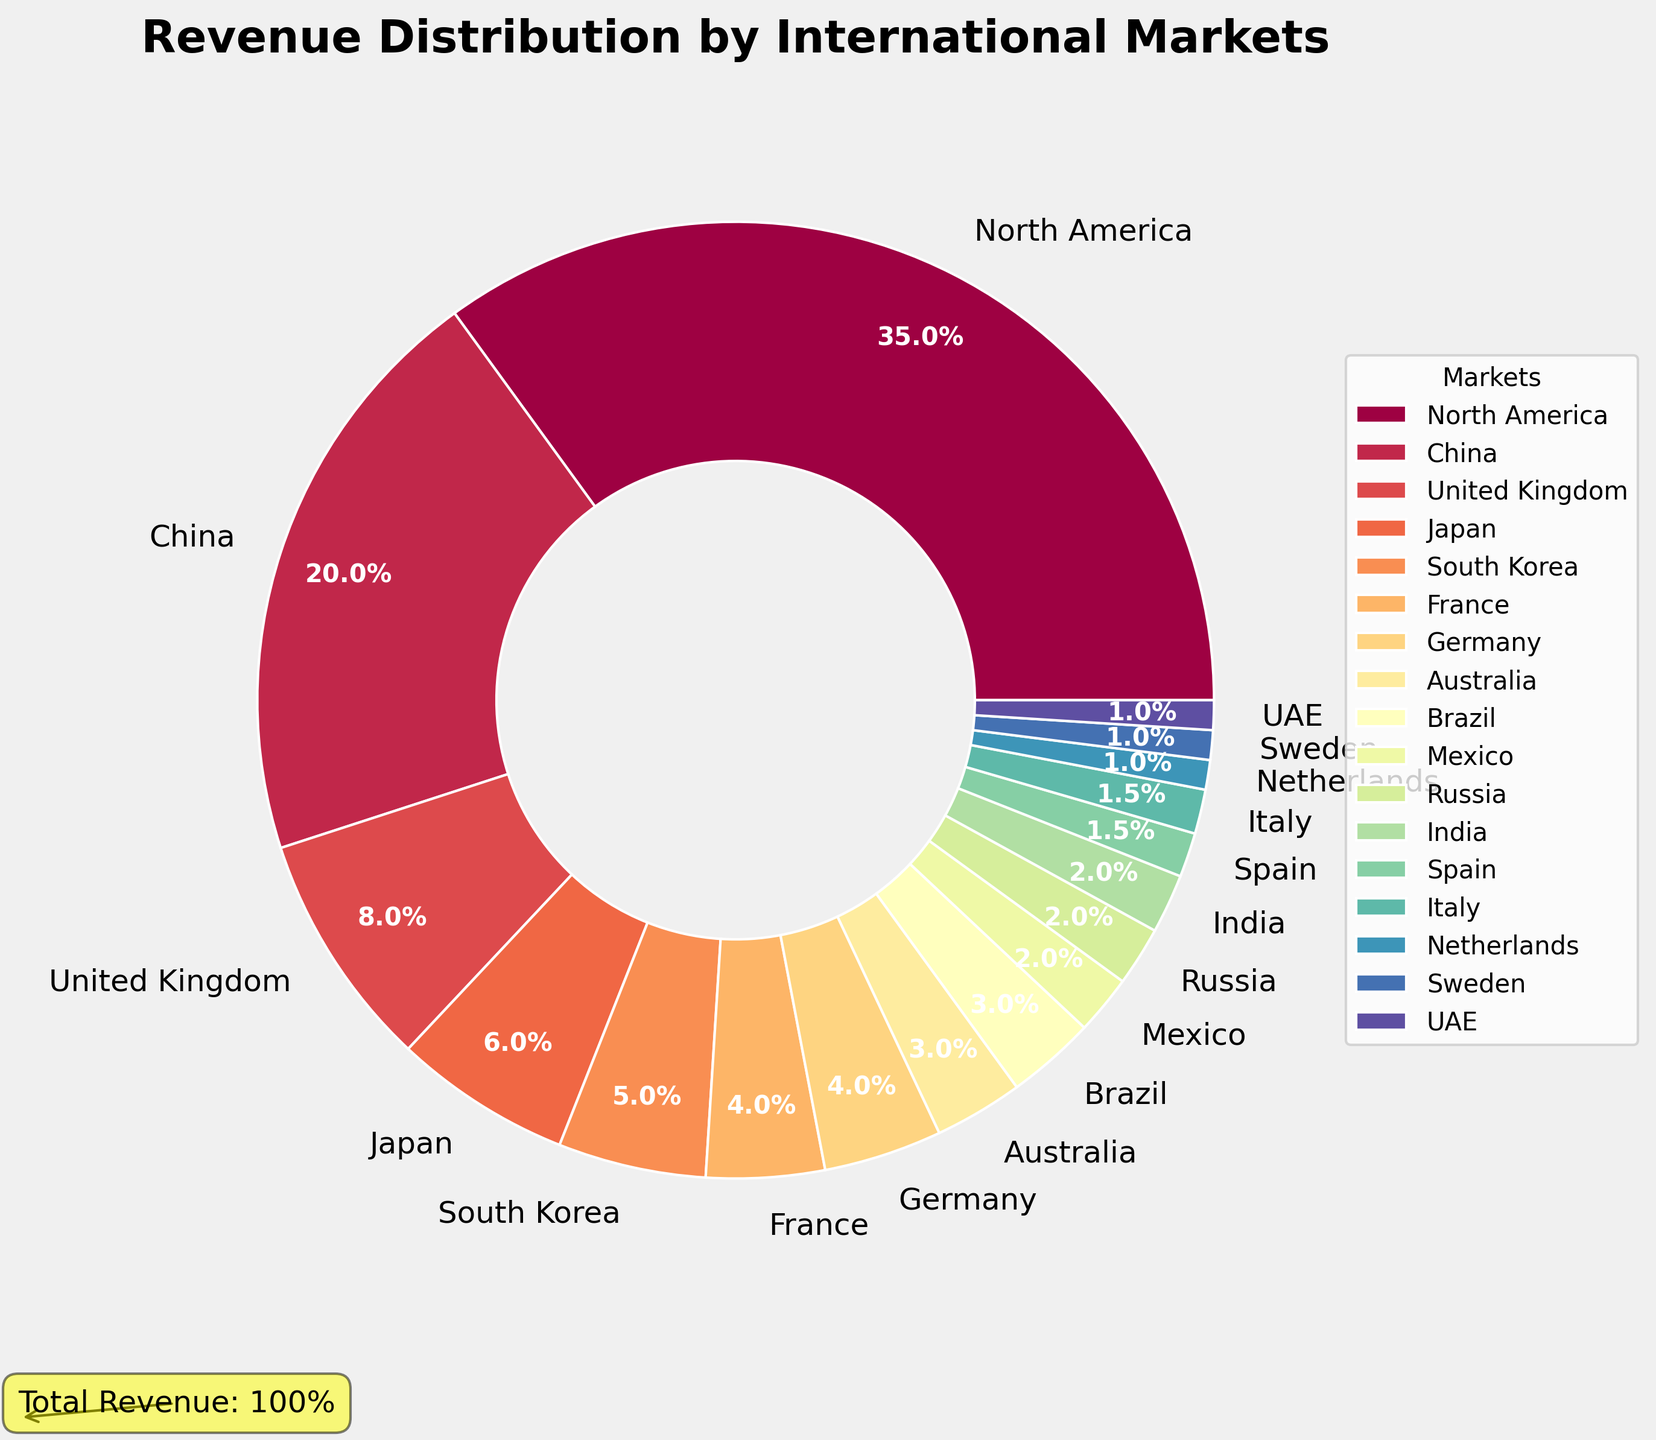What percentage of revenue does North America generate compared to China? North America generates 35% of the revenue, while China generates 20%. The comparison is 35% vs. 20%, indicating North America generates 15% more revenue than China.
Answer: 15% What's the combined revenue percentage generated by Japan, South Korea, and France? Add the percentages of Japan (6%), South Korea (5%), and France (4%). The combined revenue is 6% + 5% + 4% = 15%.
Answer: 15% Which market contributes less to the revenue: Mexico or Russia? Mexico contributes 2% and Russia also contributes 2%. They both contribute the same percentage.
Answer: They are equal What is the total percentage of revenue generated by markets contributing less than 5% each? Sum the percentages of markets contributing less than 5%: United Kingdom (8%), Japan (6%), South Korea (5%), France (4%), Germany (4%), Australia (3%), Brazil (3%), Mexico (2%), Russia (2%), India (2%), Spain (1.5%), Italy (1.5%), Netherlands (1%), Sweden (1%), UAE (1%). Total = 8% + 6% + 5% + 4% + 4% + 3% + 3% + 2% + 2% + 2% + 1.5% + 1.5% + 1% + 1% + 1% = 45%.
Answer: 65% How much more revenue does the United Kingdom generate compared to Australia and Brazil combined? The United Kingdom generates 8%, Australia generates 3%, and Brazil generates 3%. The combined revenue of Australia and Brazil is 3% + 3% = 6%. The difference is 8% - 6% = 2%.
Answer: 2% What percentage of the total revenue is generated by European markets? Add the percentages of the European markets: United Kingdom (8%), France (4%), Germany (4%), Spain (1.5%), Italy (1.5%), Netherlands (1%), and Sweden (1%). The sum is 8% + 4% + 4% + 1.5% + 1.5% + 1% + 1% = 21%.
Answer: 21% Which market contributes more, Japan or South Korea? Japan contributes 6%, while South Korea contributes 5%. Therefore, Japan contributes more.
Answer: Japan Identify the market with the third-highest revenue contribution and state its percentage. The markets with the highest revenue contributions are North America (35%), China (20%), and the United Kingdom (8%). The third highest is the United Kingdom with 8%.
Answer: United Kingdom, 8% 